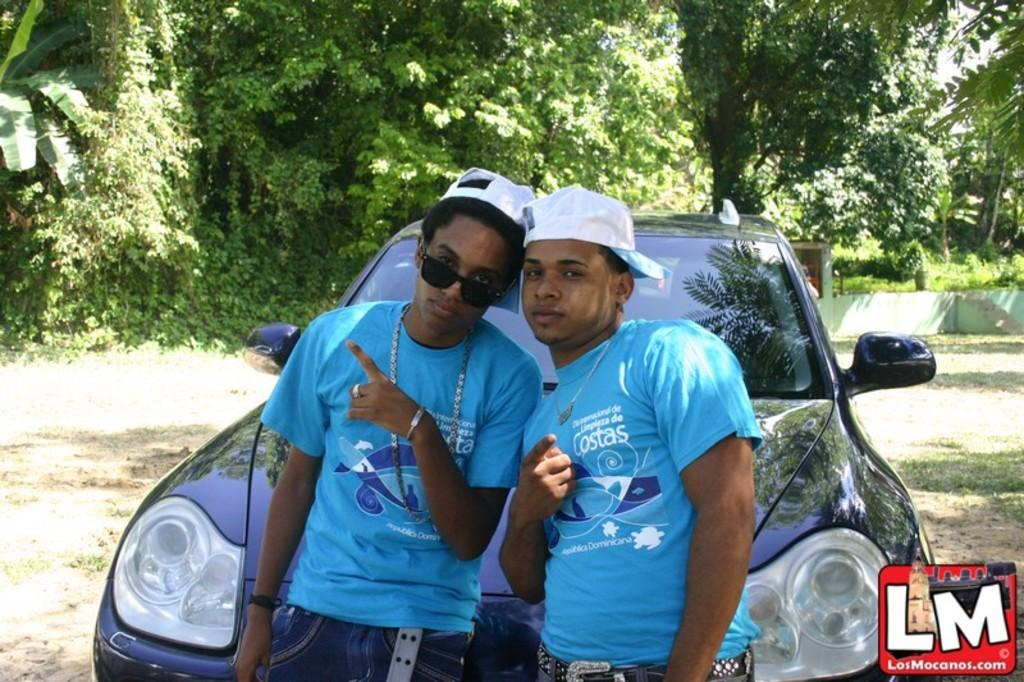How many people are in the image? There are two boys in the image. What are the boys wearing? The boys are wearing clothes. What object can be seen in the image besides the boys? There is a car in the image. What type of natural environment is visible in the image? There are trees in the image. Where is the throne located in the image? There is no throne present in the image. Can you describe the boys' breathing patterns in the image? The image does not show the boys' breathing patterns, as it is a still image. 